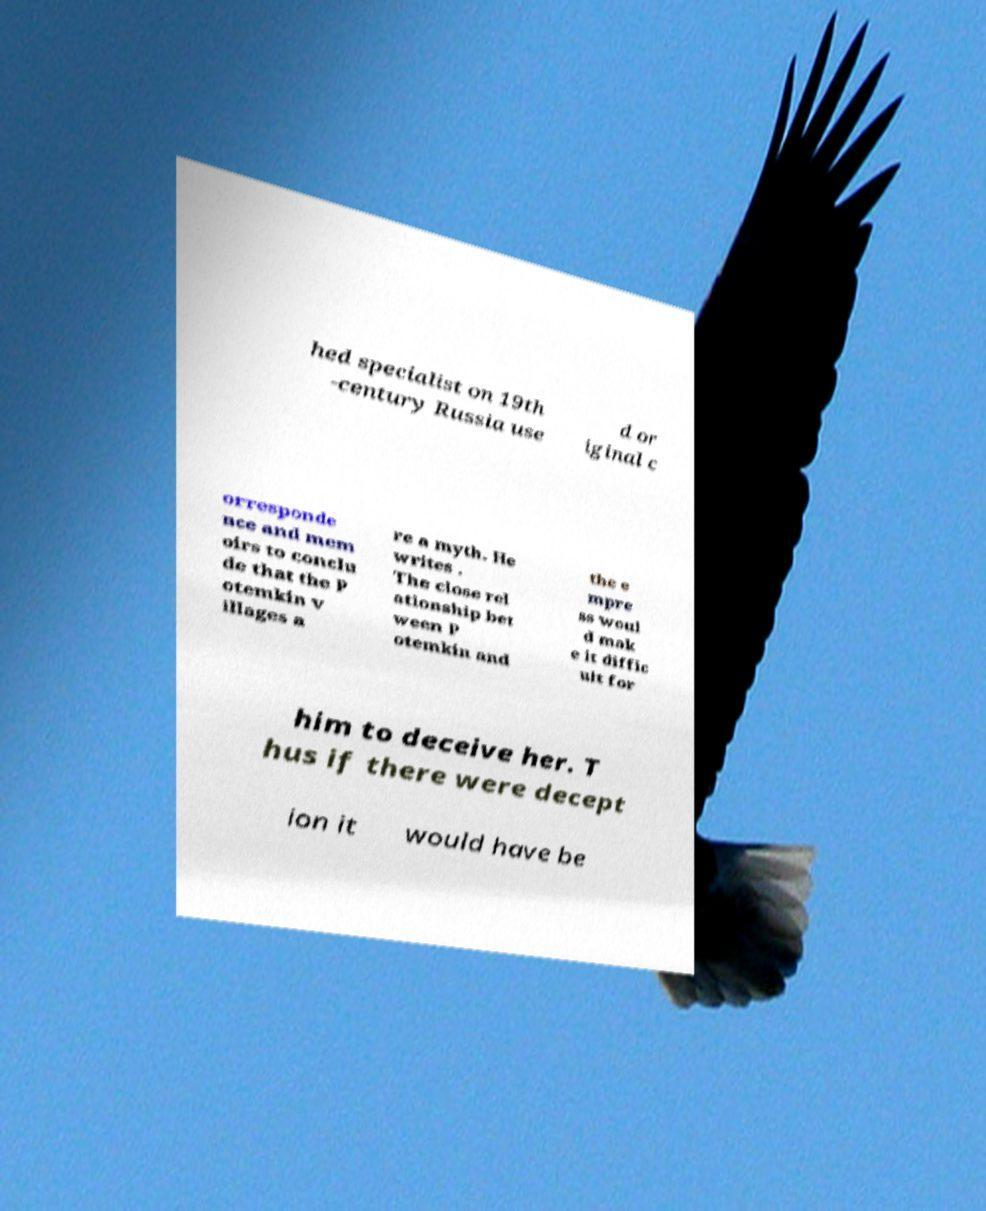I need the written content from this picture converted into text. Can you do that? hed specialist on 19th -century Russia use d or iginal c orresponde nce and mem oirs to conclu de that the P otemkin v illages a re a myth. He writes . The close rel ationship bet ween P otemkin and the e mpre ss woul d mak e it diffic ult for him to deceive her. T hus if there were decept ion it would have be 